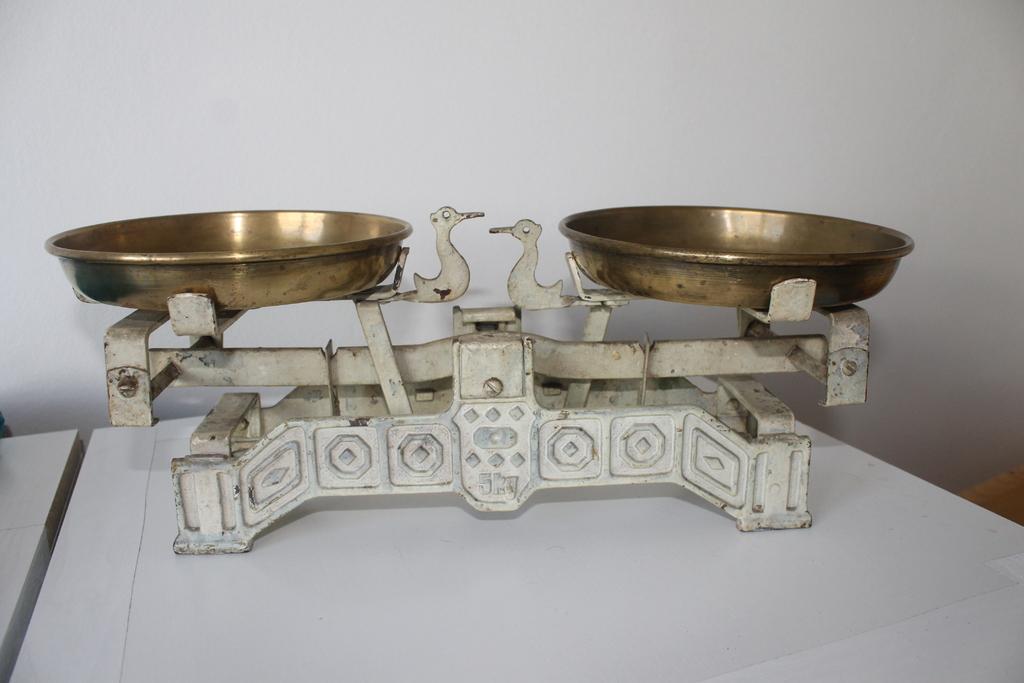How would you summarize this image in a sentence or two? In the center of the image there is a weighing machine on the table. In the background of the image there is wall. 